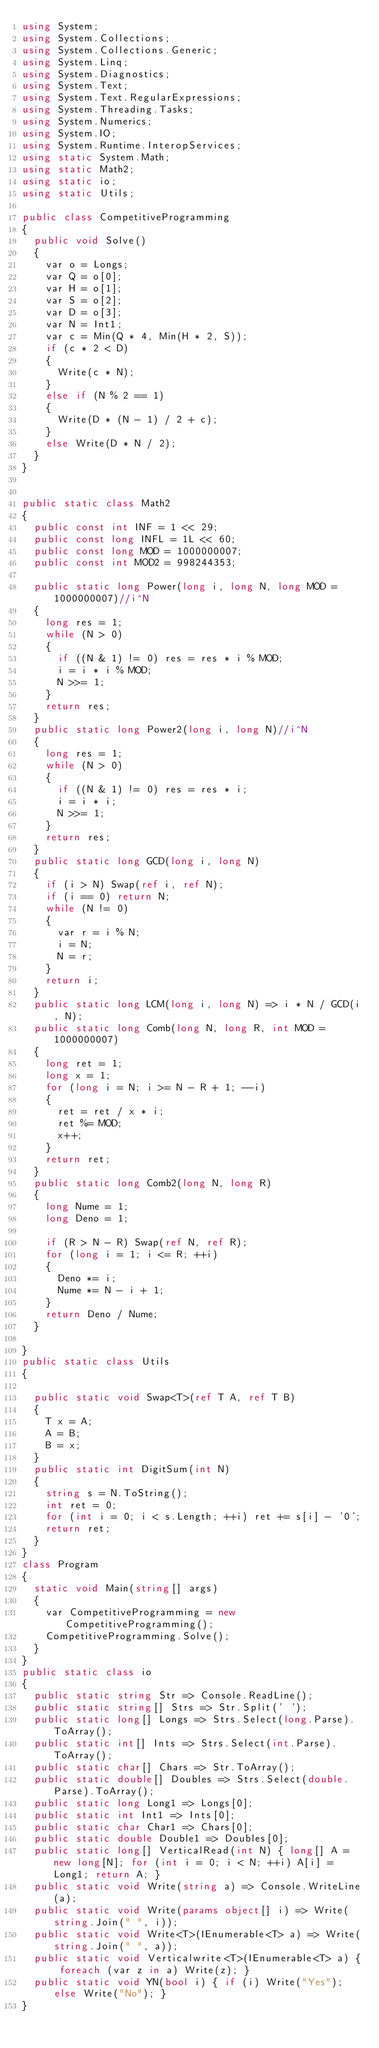Convert code to text. <code><loc_0><loc_0><loc_500><loc_500><_C#_>using System;
using System.Collections;
using System.Collections.Generic;
using System.Linq;
using System.Diagnostics;
using System.Text;
using System.Text.RegularExpressions;
using System.Threading.Tasks;
using System.Numerics;
using System.IO;
using System.Runtime.InteropServices;
using static System.Math;
using static Math2;
using static io;
using static Utils;

public class CompetitiveProgramming
{
  public void Solve()
  {
    var o = Longs;
    var Q = o[0];
    var H = o[1];
    var S = o[2];
    var D = o[3];
    var N = Int1;
    var c = Min(Q * 4, Min(H * 2, S));
    if (c * 2 < D)
    {
      Write(c * N);
    }
    else if (N % 2 == 1)
    {
      Write(D * (N - 1) / 2 + c);
    }
    else Write(D * N / 2);
  }
}


public static class Math2
{
  public const int INF = 1 << 29;
  public const long INFL = 1L << 60;
  public const long MOD = 1000000007;
  public const int MOD2 = 998244353;

  public static long Power(long i, long N, long MOD = 1000000007)//i^N
  {
    long res = 1;
    while (N > 0)
    {
      if ((N & 1) != 0) res = res * i % MOD;
      i = i * i % MOD;
      N >>= 1;
    }
    return res;
  }
  public static long Power2(long i, long N)//i^N
  {
    long res = 1;
    while (N > 0)
    {
      if ((N & 1) != 0) res = res * i;
      i = i * i;
      N >>= 1;
    }
    return res;
  }
  public static long GCD(long i, long N)
  {
    if (i > N) Swap(ref i, ref N);
    if (i == 0) return N;
    while (N != 0)
    {
      var r = i % N;
      i = N;
      N = r;
    }
    return i;
  }
  public static long LCM(long i, long N) => i * N / GCD(i, N);
  public static long Comb(long N, long R, int MOD = 1000000007)
  {
    long ret = 1;
    long x = 1;
    for (long i = N; i >= N - R + 1; --i)
    {
      ret = ret / x * i;
      ret %= MOD;
      x++;
    }
    return ret;
  }
  public static long Comb2(long N, long R)
  {
    long Nume = 1;
    long Deno = 1;

    if (R > N - R) Swap(ref N, ref R);
    for (long i = 1; i <= R; ++i)
    {
      Deno *= i;
      Nume *= N - i + 1;
    }
    return Deno / Nume;
  }

}
public static class Utils
{

  public static void Swap<T>(ref T A, ref T B)
  {
    T x = A;
    A = B;
    B = x;
  }
  public static int DigitSum(int N)
  {
    string s = N.ToString();
    int ret = 0;
    for (int i = 0; i < s.Length; ++i) ret += s[i] - '0';
    return ret;
  }
}
class Program
{
  static void Main(string[] args)
  {
    var CompetitiveProgramming = new CompetitiveProgramming();
    CompetitiveProgramming.Solve();
  }
}
public static class io
{
  public static string Str => Console.ReadLine();
  public static string[] Strs => Str.Split(' ');
  public static long[] Longs => Strs.Select(long.Parse).ToArray();
  public static int[] Ints => Strs.Select(int.Parse).ToArray();
  public static char[] Chars => Str.ToArray();
  public static double[] Doubles => Strs.Select(double.Parse).ToArray();
  public static long Long1 => Longs[0];
  public static int Int1 => Ints[0];
  public static char Char1 => Chars[0];
  public static double Double1 => Doubles[0];
  public static long[] VerticalRead(int N) { long[] A = new long[N]; for (int i = 0; i < N; ++i) A[i] = Long1; return A; }
  public static void Write(string a) => Console.WriteLine(a);
  public static void Write(params object[] i) => Write(string.Join(" ", i));
  public static void Write<T>(IEnumerable<T> a) => Write(string.Join(" ", a));
  public static void Verticalwrite<T>(IEnumerable<T> a) { foreach (var z in a) Write(z); }
  public static void YN(bool i) { if (i) Write("Yes"); else Write("No"); }
}
</code> 